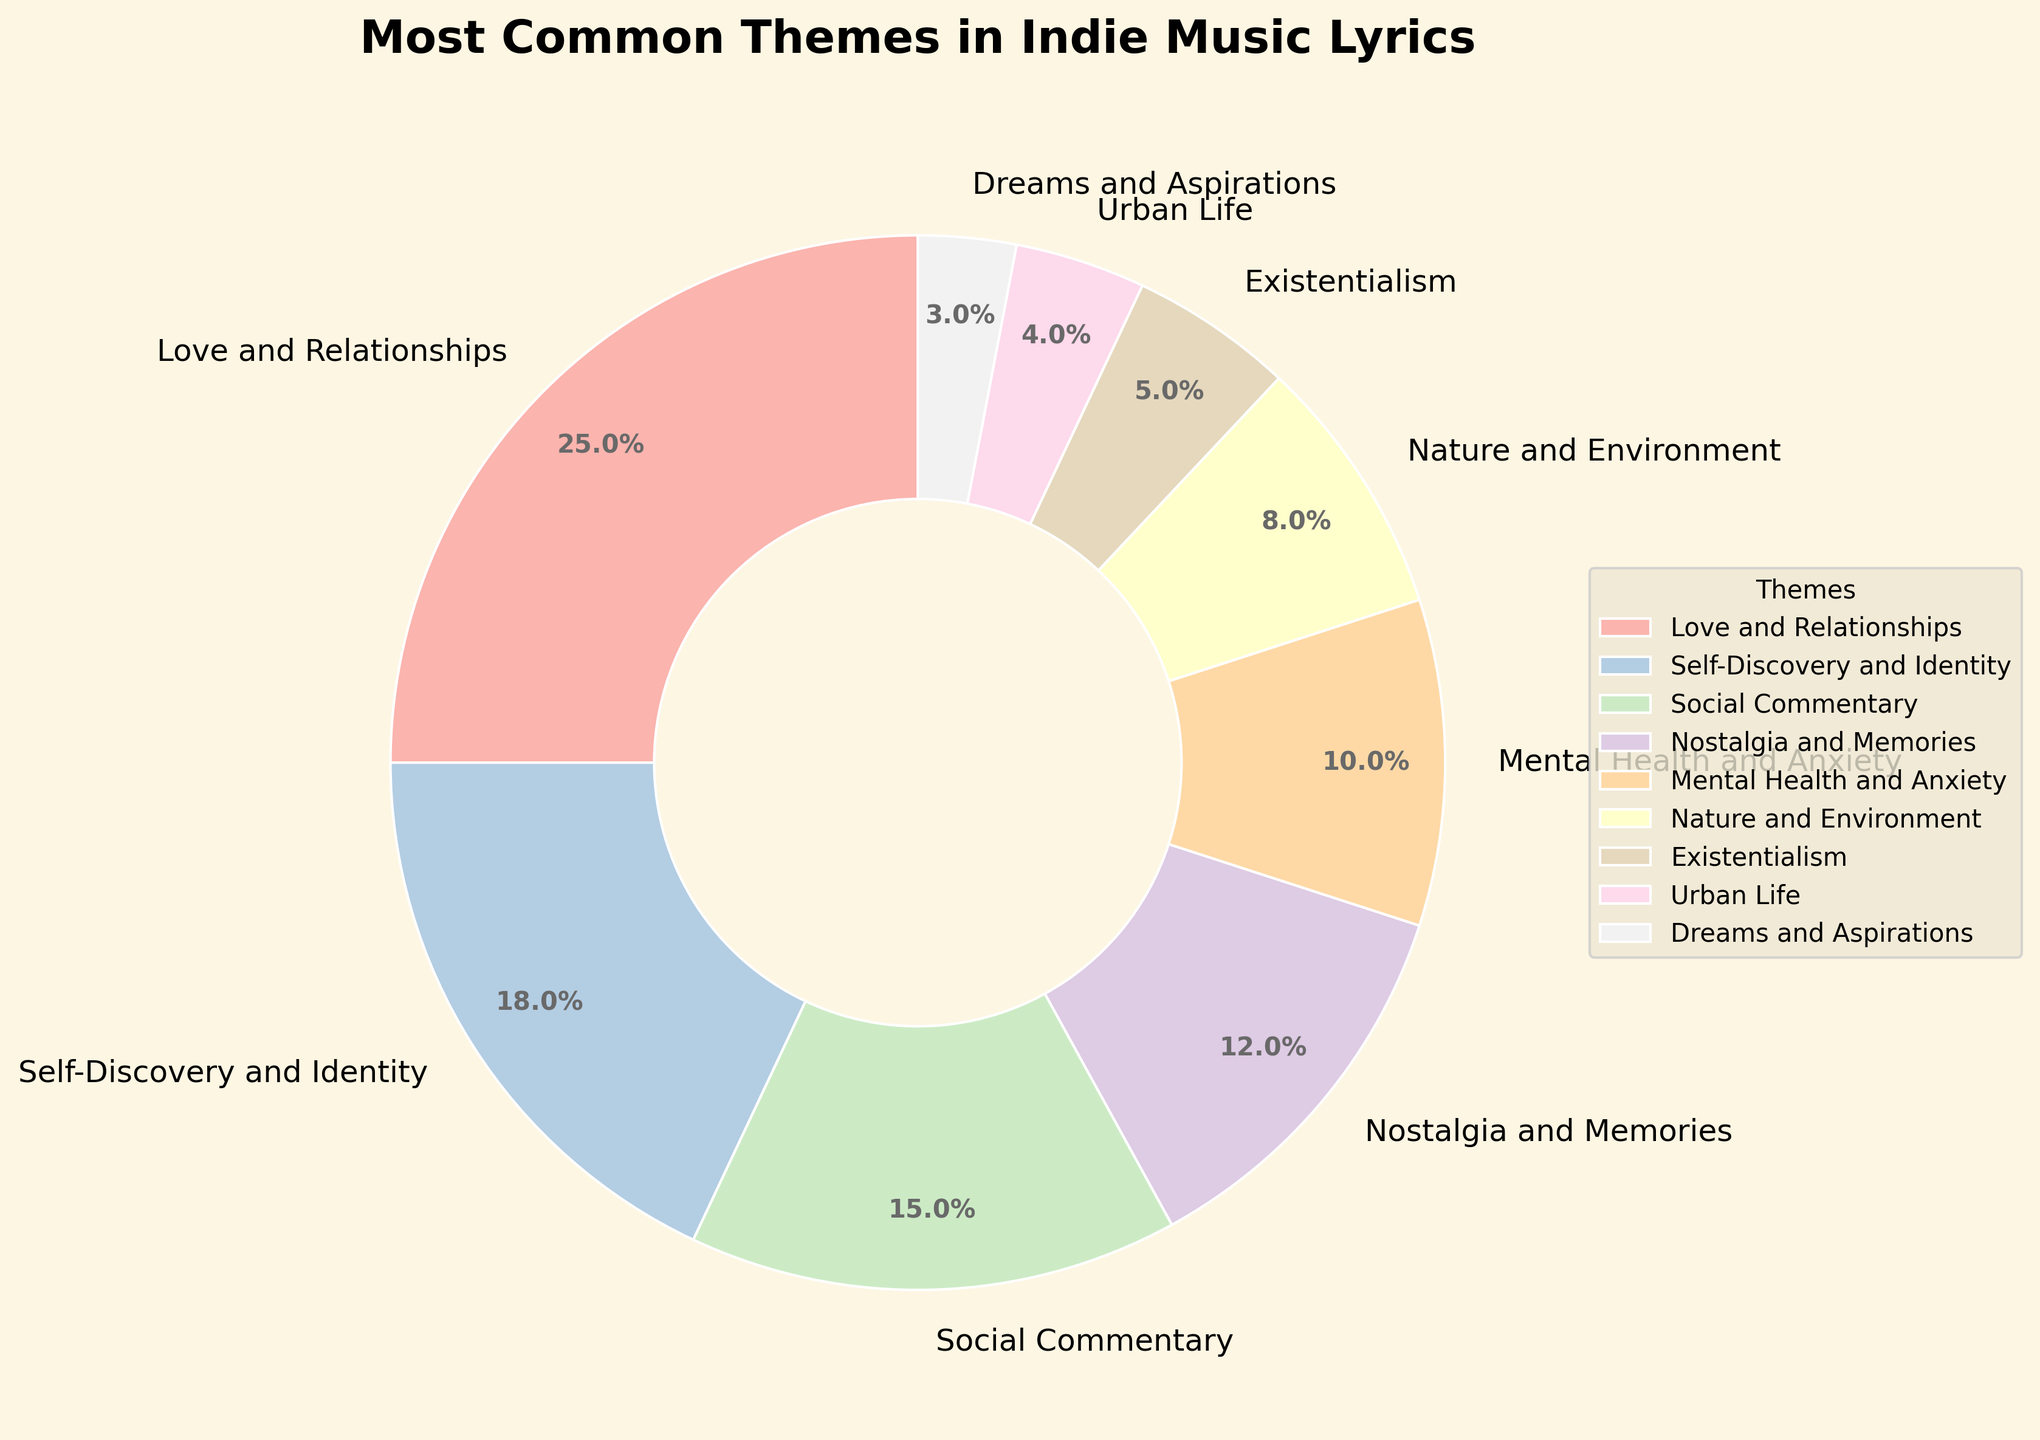Which theme is the most common in indie music lyrics based on the pie chart? The pie chart shows the percentages of different themes, and the segment labeled "Love and Relationships" has the largest portion, indicating it is the most common theme.
Answer: Love and Relationships What is the total percentage for themes related to personal issues like Mental Health and Anxiety and Self-Discovery and Identity? Add the percentages of "Mental Health and Anxiety" and "Self-Discovery and Identity": 10% + 18%.
Answer: 28% Which theme has a lower representation: Urban Life or Existentialism? Compare the segments labeled "Urban Life" and "Existentialism" on the chart. "Urban Life" covers 4%, while "Existentialism" covers 5%.
Answer: Urban Life How much larger is the percentage of Nostalgia and Memories compared to Nature and Environment? Subtract the percentage of "Nature and Environment" from the percentage of "Nostalgia and Memories": 12% - 8%.
Answer: 4% What is the combined percentage of themes focusing on social and environmental issues (Social Commentary and Nature and Environment)? Add the percentages of "Social Commentary" and "Nature and Environment": 15% + 8%.
Answer: 23% Compare the percentage representation of Love and Relationships and Dreams and Aspirations. How many times larger is one than the other? Divide the percentage of "Love and Relationships" by the percentage of "Dreams and Aspirations": 25% / 3%.
Answer: 8.33 Which themes together make up more than 50% of the chart? Add the percentages from the dominant themes in order until the total surpasses 50%: Love and Relationships (25%) + Self-Discovery and Identity (18%) + Social Commentary (15%).
Answer: Love and Relationships, Self-Discovery and Identity, Social Commentary Does the theme of Nature and Environment have a higher or lower representation than Mental Health and Anxiety? Compare the segments labeled "Nature and Environment" and "Mental Health and Anxiety" on the chart. "Nature and Environment" covers 8%, while "Mental Health and Anxiety" covers 10%.
Answer: Lower What percentage of themes fall under Urban Life and Existentialism combined? Add the percentages of "Urban Life" and "Existentialism": 4% + 5%.
Answer: 9% 